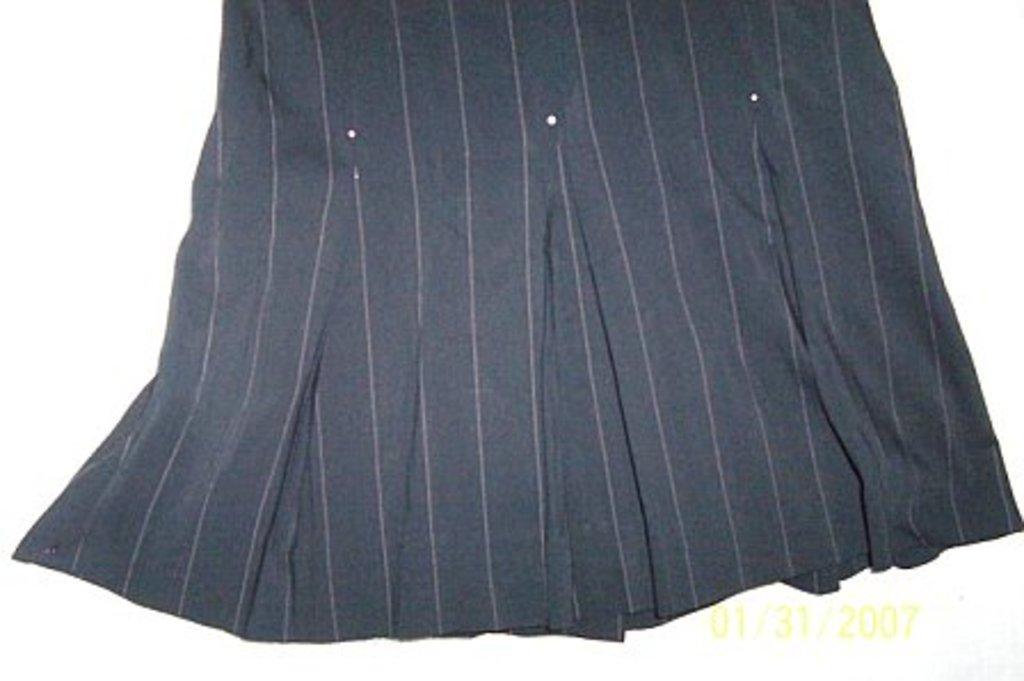Describe this image in one or two sentences. In this picture there is a black cloth which has few pink lines on it and there is something written in the right corner. 